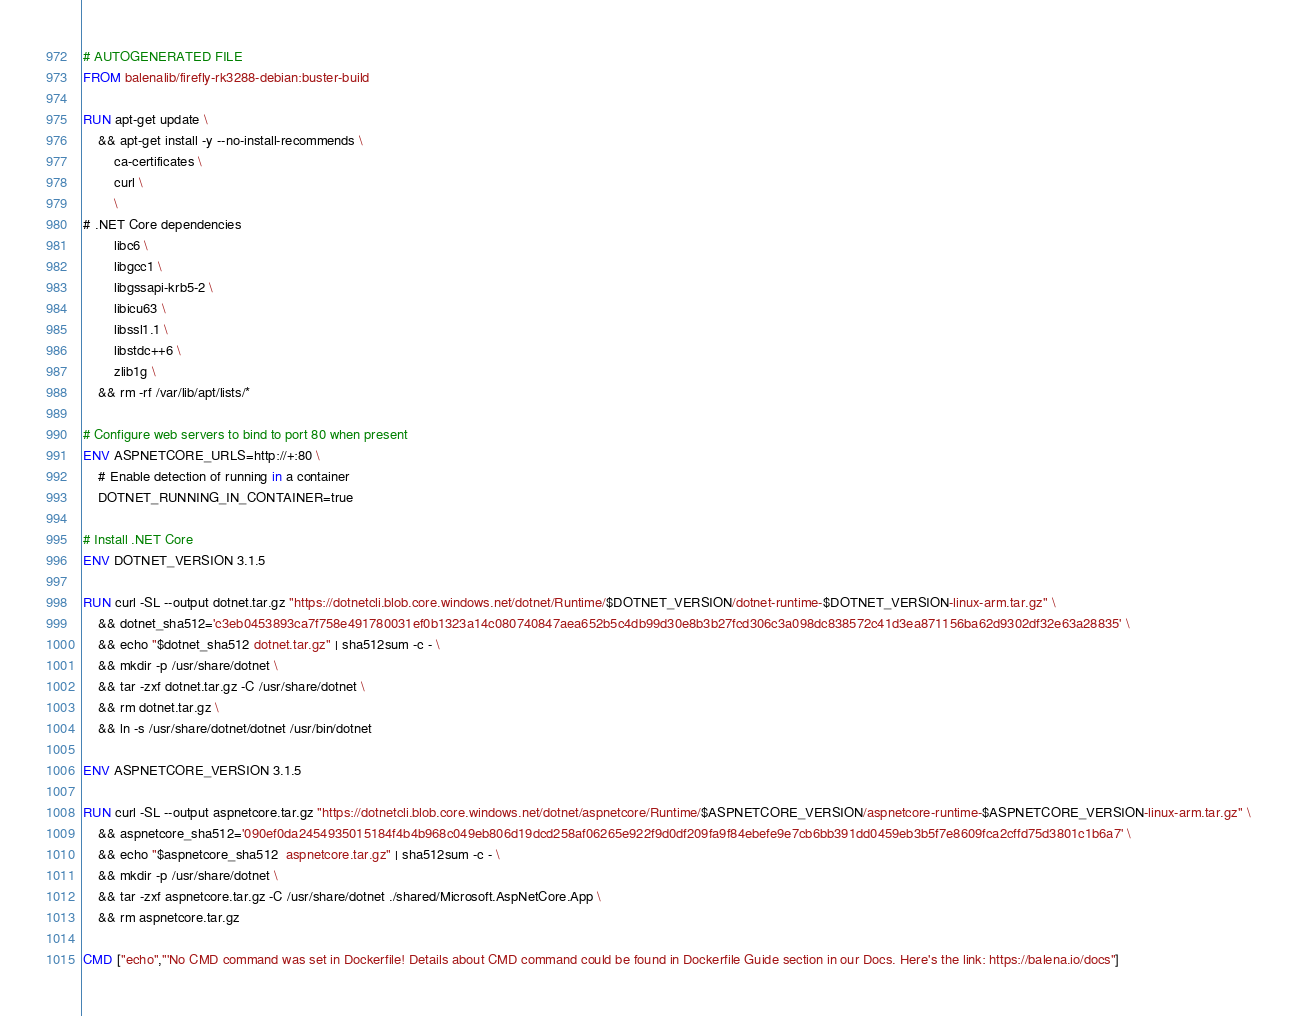Convert code to text. <code><loc_0><loc_0><loc_500><loc_500><_Dockerfile_># AUTOGENERATED FILE
FROM balenalib/firefly-rk3288-debian:buster-build

RUN apt-get update \
    && apt-get install -y --no-install-recommends \
        ca-certificates \
        curl \
        \
# .NET Core dependencies
        libc6 \
        libgcc1 \
        libgssapi-krb5-2 \
        libicu63 \
        libssl1.1 \
        libstdc++6 \
        zlib1g \
    && rm -rf /var/lib/apt/lists/*

# Configure web servers to bind to port 80 when present
ENV ASPNETCORE_URLS=http://+:80 \
    # Enable detection of running in a container
    DOTNET_RUNNING_IN_CONTAINER=true

# Install .NET Core
ENV DOTNET_VERSION 3.1.5

RUN curl -SL --output dotnet.tar.gz "https://dotnetcli.blob.core.windows.net/dotnet/Runtime/$DOTNET_VERSION/dotnet-runtime-$DOTNET_VERSION-linux-arm.tar.gz" \
    && dotnet_sha512='c3eb0453893ca7f758e491780031ef0b1323a14c080740847aea652b5c4db99d30e8b3b27fcd306c3a098dc838572c41d3ea871156ba62d9302df32e63a28835' \
    && echo "$dotnet_sha512 dotnet.tar.gz" | sha512sum -c - \
    && mkdir -p /usr/share/dotnet \
    && tar -zxf dotnet.tar.gz -C /usr/share/dotnet \
    && rm dotnet.tar.gz \
    && ln -s /usr/share/dotnet/dotnet /usr/bin/dotnet

ENV ASPNETCORE_VERSION 3.1.5

RUN curl -SL --output aspnetcore.tar.gz "https://dotnetcli.blob.core.windows.net/dotnet/aspnetcore/Runtime/$ASPNETCORE_VERSION/aspnetcore-runtime-$ASPNETCORE_VERSION-linux-arm.tar.gz" \
    && aspnetcore_sha512='090ef0da2454935015184f4b4b968c049eb806d19dcd258af06265e922f9d0df209fa9f84ebefe9e7cb6bb391dd0459eb3b5f7e8609fca2cffd75d3801c1b6a7' \
    && echo "$aspnetcore_sha512  aspnetcore.tar.gz" | sha512sum -c - \
    && mkdir -p /usr/share/dotnet \
    && tar -zxf aspnetcore.tar.gz -C /usr/share/dotnet ./shared/Microsoft.AspNetCore.App \
    && rm aspnetcore.tar.gz

CMD ["echo","'No CMD command was set in Dockerfile! Details about CMD command could be found in Dockerfile Guide section in our Docs. Here's the link: https://balena.io/docs"]
</code> 